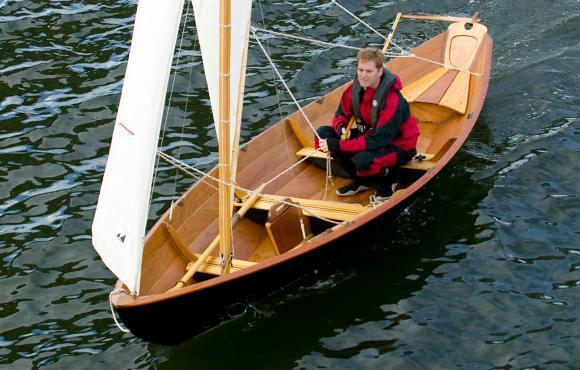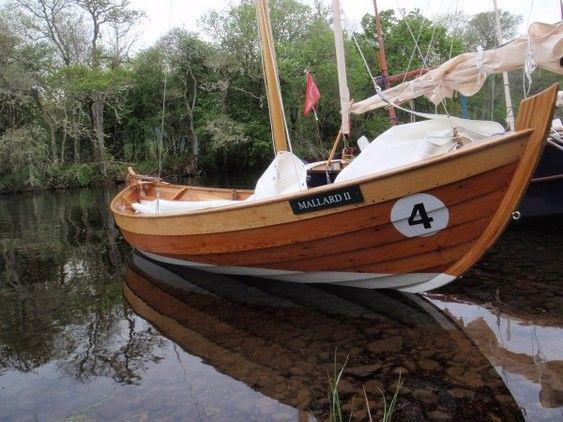The first image is the image on the left, the second image is the image on the right. Evaluate the accuracy of this statement regarding the images: "One person is in a sailboat in the image on the left.". Is it true? Answer yes or no. Yes. The first image is the image on the left, the second image is the image on the right. Assess this claim about the two images: "The left image shows exactly one boat, which has an upright sail and one rider inside.". Correct or not? Answer yes or no. Yes. 